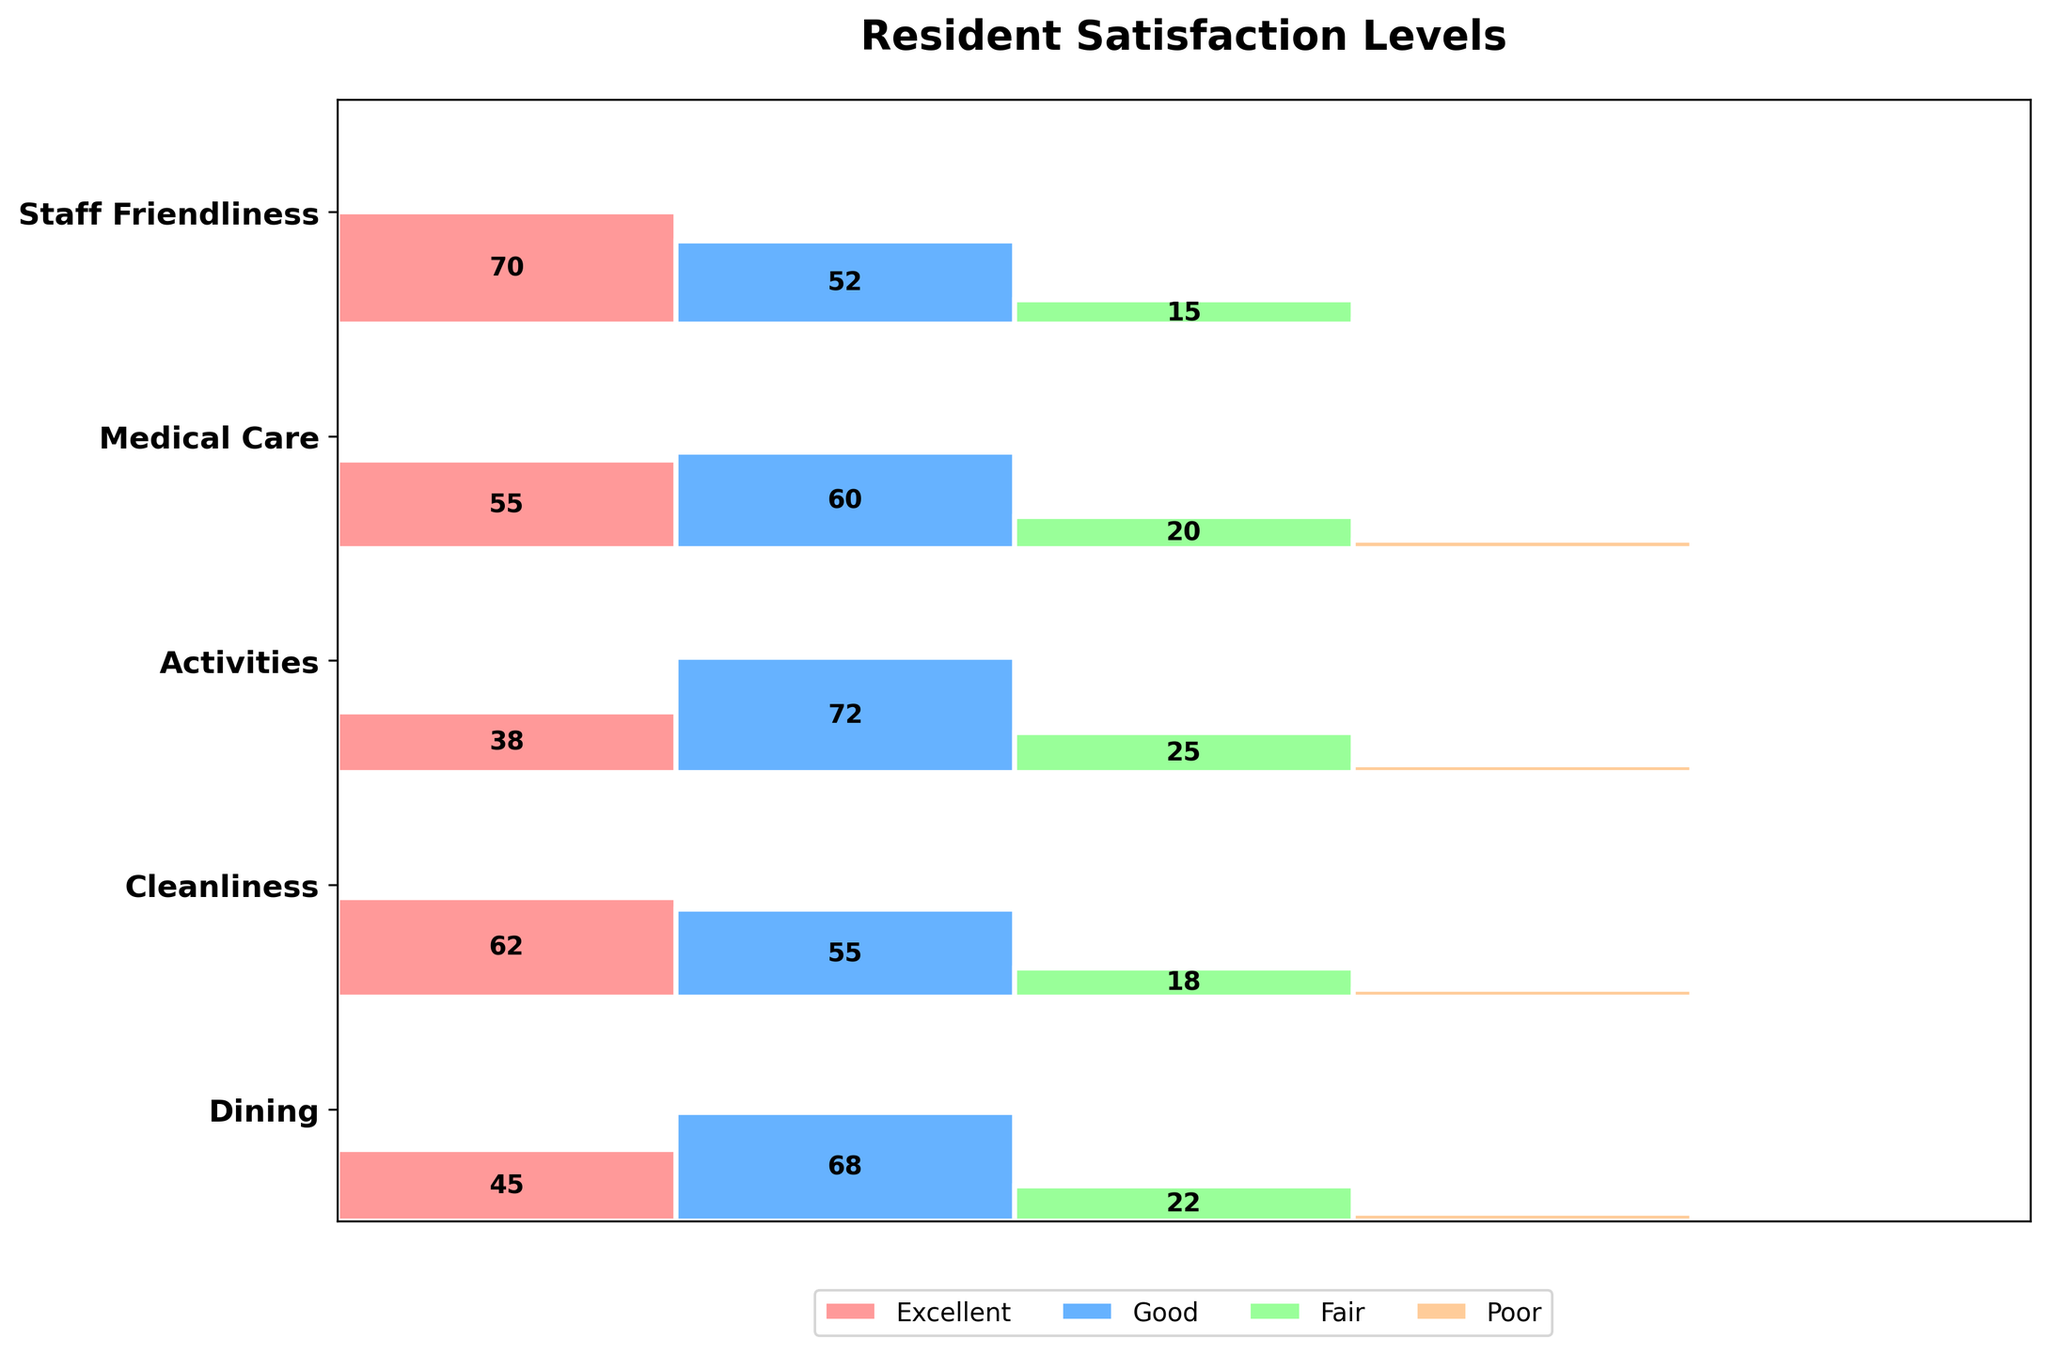what are the main aspects being evaluated for resident satisfaction? The main aspects can be found on the y-axis, which lists them clearly. The y-axis includes Dining, Cleanliness, Activities, Medical Care, and Staff Friendliness
Answer: Dining, Cleanliness, Activities, Medical Care, Staff Friendliness Which aspect has the highest number of 'Excellent' ratings? Count the height of the 'Excellent' section for each aspect and identify the highest one. Staff Friendliness has the highest number of 'Excellent' ratings because its 'Excellent' section is the tallest
Answer: Staff Friendliness How does the satisfaction with 'Dining' compare between 'Good' and 'Fair' ratings? Look at the sizes of the rectangles for 'Good' and 'Fair' under Dining. The 'Good' rectangle is larger than the 'Fair' rectangle, indicating more 'Good' ratings than 'Fair'
Answer: Good > Fair Which aspect has the smallest 'Poor' rating? Identify the 'Poor' sections for each aspect and compare their sizes. Staff Friendliness has the smallest 'Poor' rating as the rectangle is smallest or non-existent
Answer: Staff Friendliness What is the sum of all 'Excellent' ratings across all aspects? Add the values of 'Excellent' for Dining (45), Cleanliness (62), Activities (38), Medical Care (55), and Staff Friendliness (70). The sum is 45 + 62 + 38 + 55 + 70 = 270
Answer: 270 Which aspect has the largest proportion of 'Fair' ratings? Compare the proportions of 'Fair' within each aspect. Look for the largest sized 'Fair' rectangle relative to its aspect. Activities seem to have the largest proportion of 'Fair' ratings
Answer: Activities How do the satisfaction ratings for 'Medical Care' and 'Cleanliness' compare for 'Good' and 'Fair'? Compare the sizes of 'Good' and 'Fair' sections for both 'Medical Care' and 'Cleanliness'. Both have relatively similar 'Good' sections, but Medical Care has a slightly larger 'Fair' section than Cleanliness
Answer: Similar in Good, Medical Care > Cleanliness in Fair In terms of visualization, what does the width of each aspect represent? The width of each aspect represents the total ratings (sum of all categories) for that aspect. Wider rectangles indicate a higher number of overall ratings
Answer: Total number of ratings per aspect Are there any aspects where all rating categories (Excellent, Good, Fair, Poor) are equally represented? Visually check if any aspect has almost the same height for all rating categories. No aspect has all rating categories equally represented; they all show varying sizes
Answer: No 